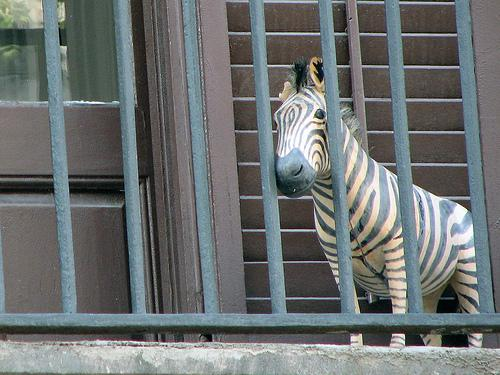Question: what is the subject of the photo?
Choices:
A. Tree.
B. Bears.
C. Statue of animal.
D. Flowers.
Answer with the letter. Answer: C Question: how many verticle black bars are fully visible?
Choices:
A. Three.
B. Four.
C. Seven.
D. Two.
Answer with the letter. Answer: C 